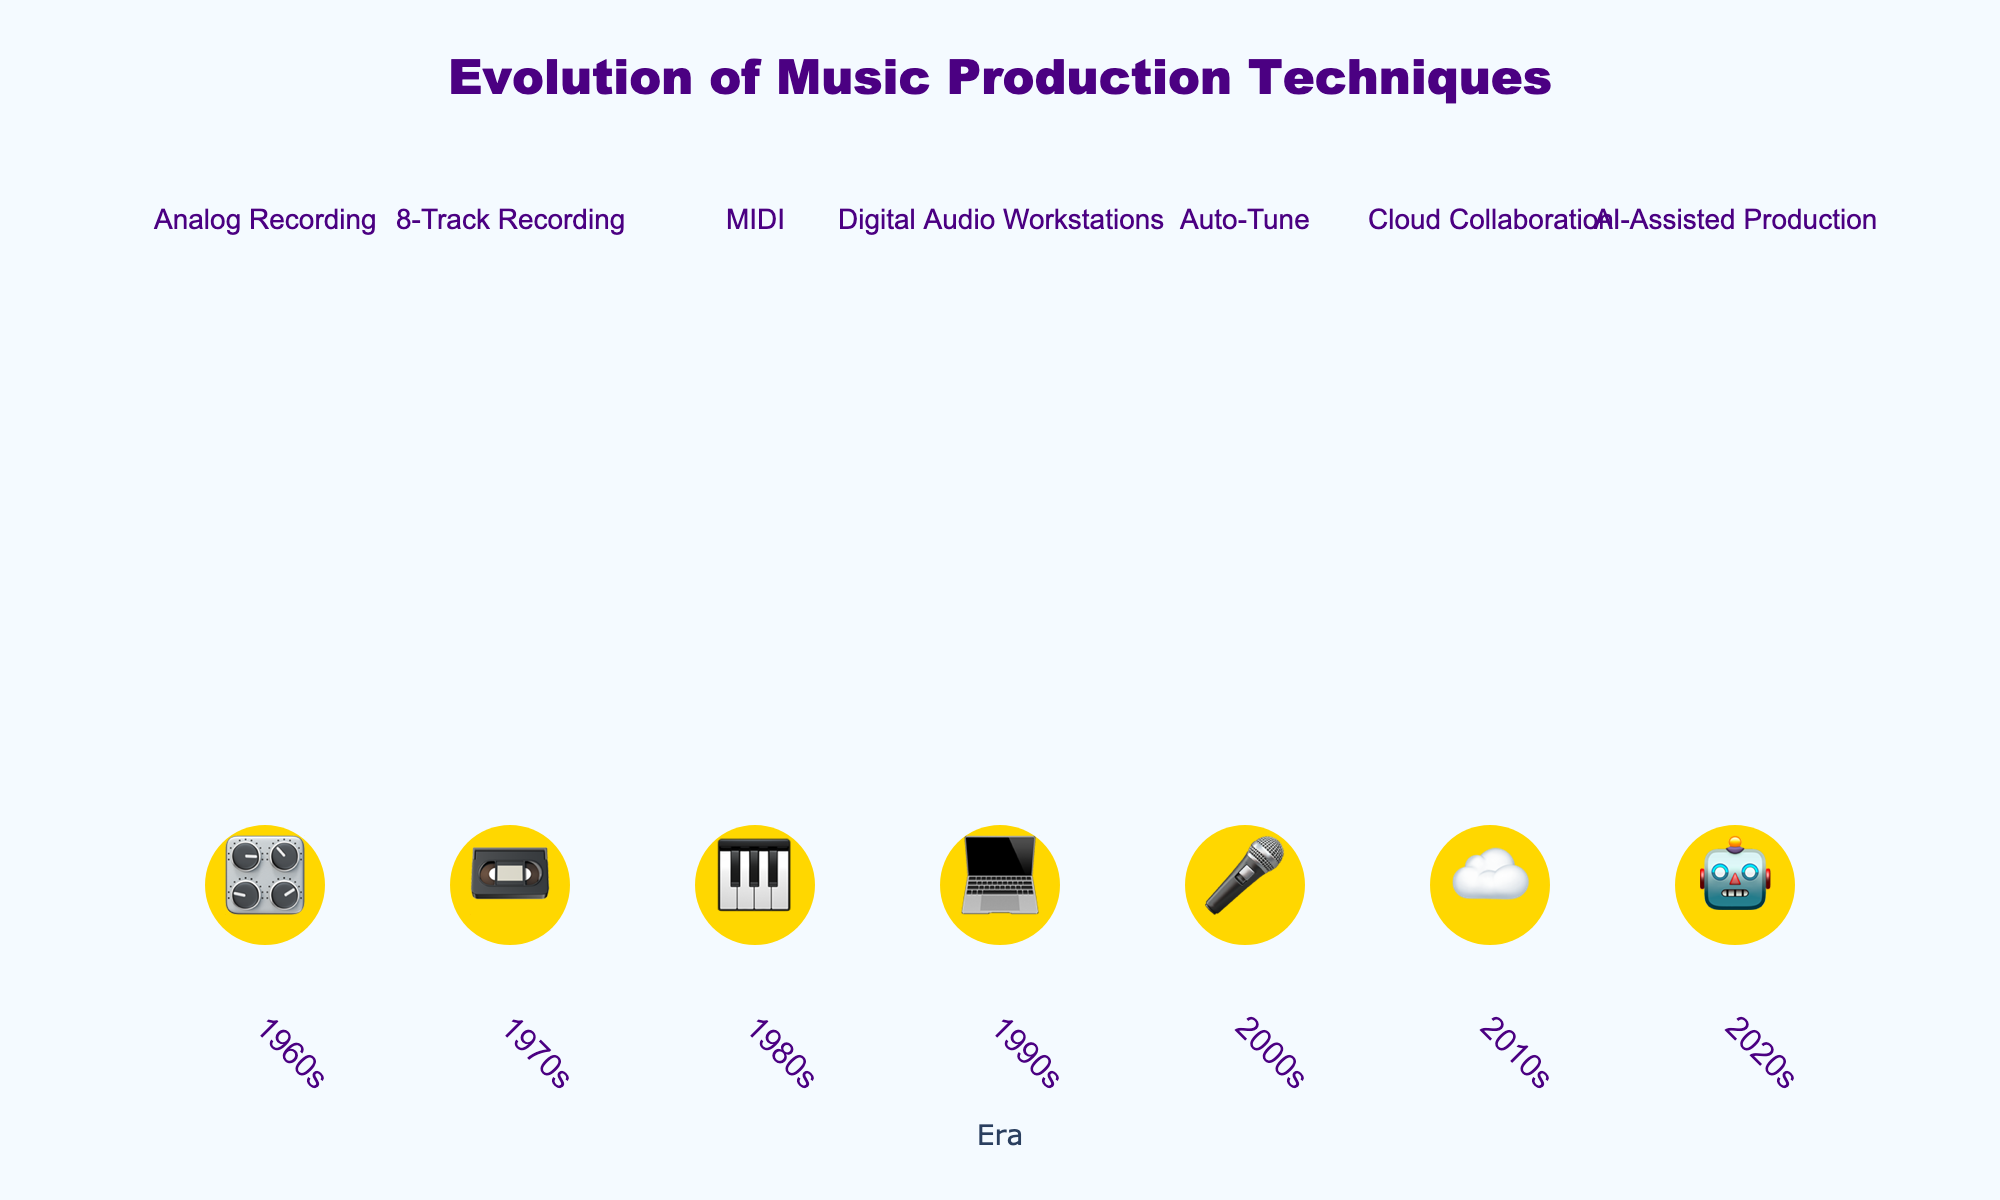What is the title of the plot? The title is displayed prominently at the top-center of the plot. It reads "Evolution of Music Production Techniques".
Answer: Evolution of Music Production Techniques Which era marks the start of digital audio workstations according to the plot? The plot lists the eras chronologically from left to right. The 1990s, represented by a 💻 emoji, marks the start of digital audio workstations.
Answer: 1990s What iconic equipment is associated with the 2000s in the plot? The 2000s are listed in chronological order on the x-axis, and the associated emoji and information are 🎤 for Auto-Tune, featuring Antares Auto-Tune as the iconic equipment.
Answer: Antares Auto-Tune Compare the span between the introduction of MIDI and AI-Assisted Production. MIDI was introduced in the 1980s and AI-Assisted Production in the 2020s. The span between them is calculated by subtracting 1980 from 2020, giving 40 years.
Answer: 40 years How many unique eras are highlighted in the plot? Each era is marked along the x-axis with a corresponding emoji, starting from the 1960s to the 2020s. Counting each era gives us 7 unique eras.
Answer: 7 What technique is linked with the cloud collaboration era? Reading the plot, the 2010s are identified with a cloud symbol (☁️), and the listed technique is Cloud Collaboration.
Answer: Cloud Collaboration Which eras are closest to each other in terms of technological advancements? Observing the plot, the 1960s, marked with 🎛️ for Analog Recording, and the 1970s, marked with 📼 for 8-Track Recording, are next to each other chronologically.
Answer: 1960s and 1970s What is the total number of techniques mentioned in the plot? Each era has one unique technique listed next to its emoji, summing these up results in a total of 7 techniques.
Answer: 7 What is the iconic equipment associated with AI-Assisted Production? The emoji 🤖 linked to AI-Assisted Production in the 2020s denotes iZotope Neutron as the iconic equipment.
Answer: iZotope Neutron 